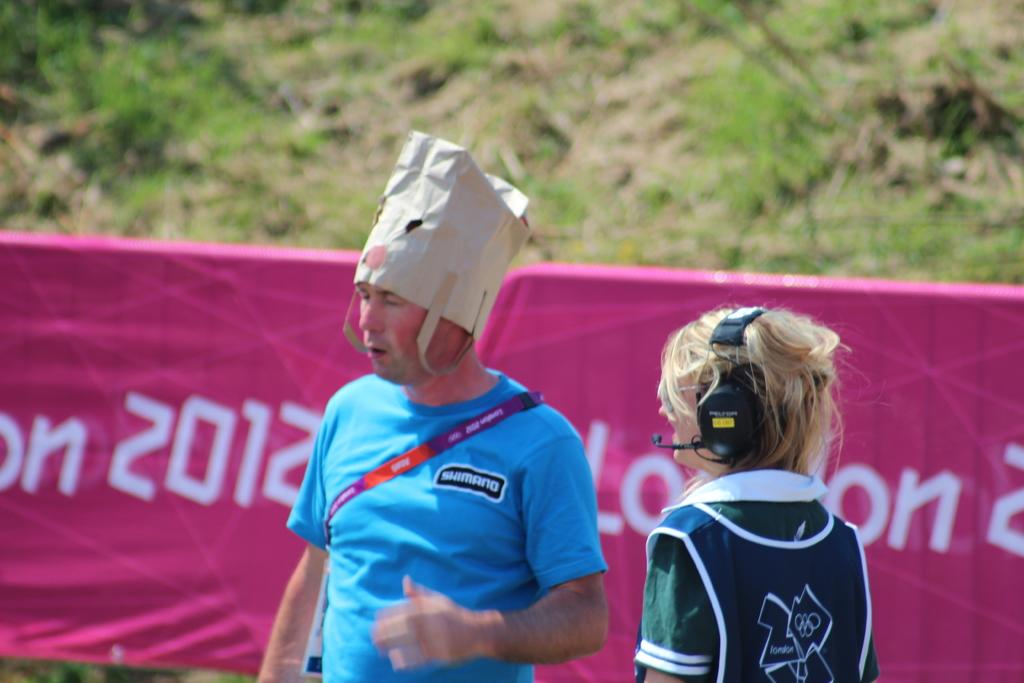<image>
Create a compact narrative representing the image presented. Man wearing a bag on his head near a pink banner that has the year 2012. 